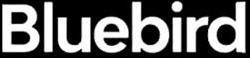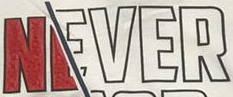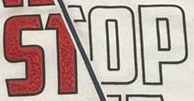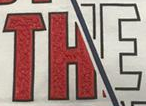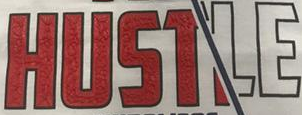Transcribe the words shown in these images in order, separated by a semicolon. Bluebird; NEVER; STOP; THE; HUSTLE 